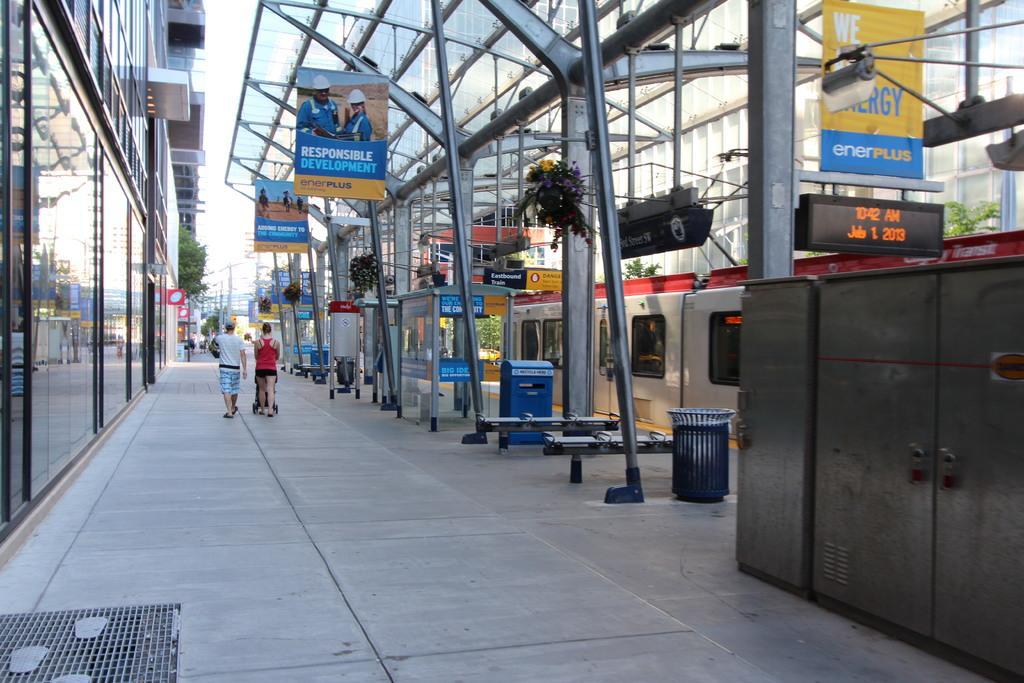Could you give a brief overview of what you see in this image? This image is taken outdoors. At the bottom of the image there is a floor. On the right side of the image there are many iron bars. There are many boards with text on them. There is a dustbin on the floor. There are a few cabins and there is a building and there are a few trees. On the left side of the image there is a building with walls, windows and a roof. There is a tree. In the middle of the image a man and a woman are walking on the floor and there is a plant in the pot. 